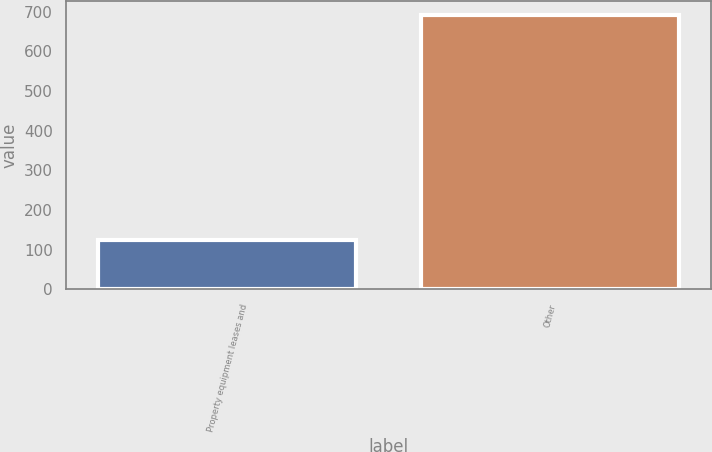Convert chart to OTSL. <chart><loc_0><loc_0><loc_500><loc_500><bar_chart><fcel>Property equipment leases and<fcel>Other<nl><fcel>124<fcel>692<nl></chart> 